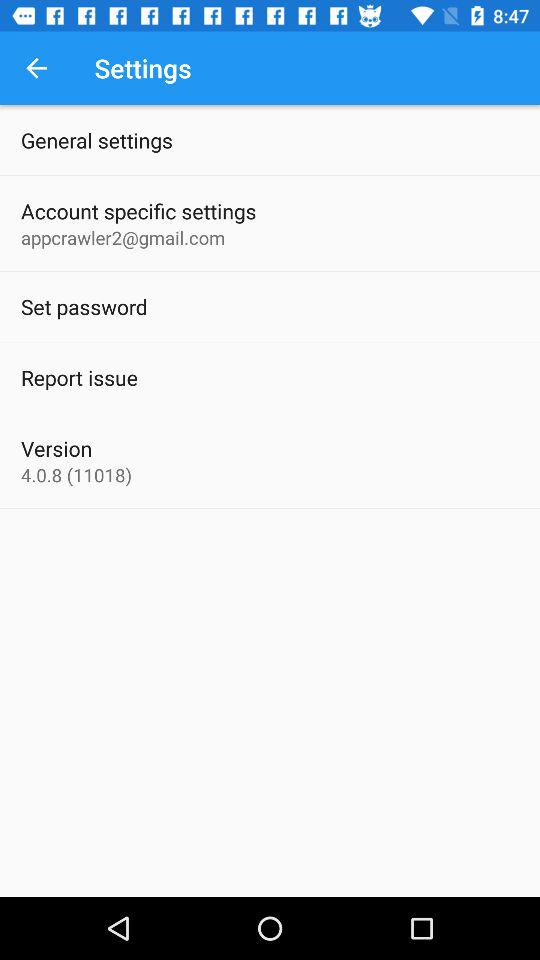What is the version? The version is 4.0.8 (11018). 